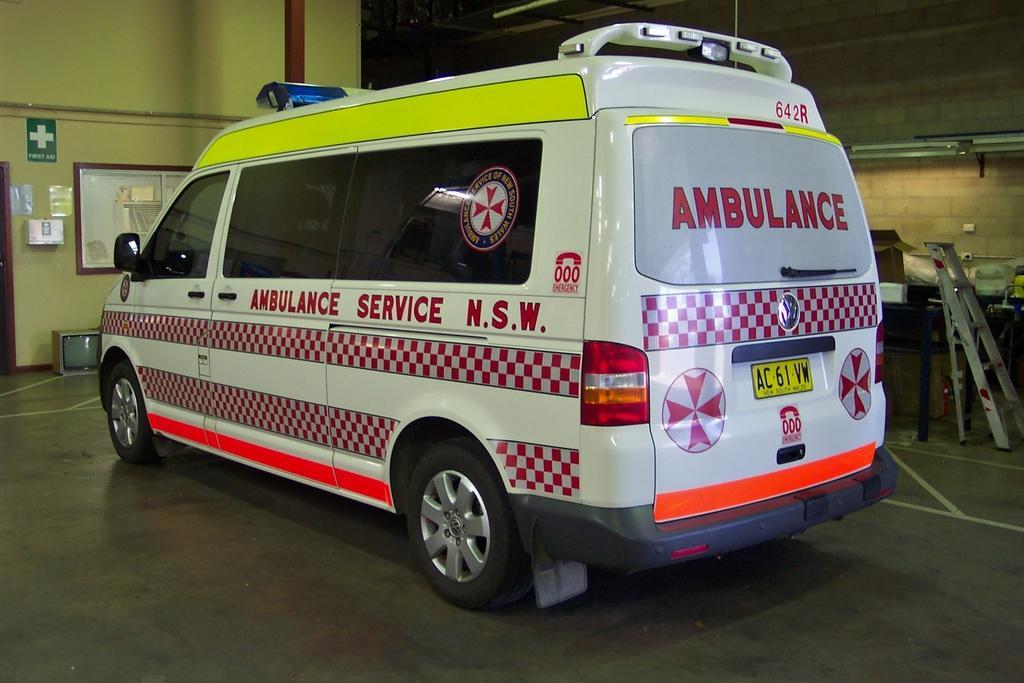In one or two sentences, can you explain what this image depicts? In this picture there is a vehicle and there is a text on the vehicle. On the left side of the image there is a board and there is a box and there are posters on the wall. There is a door and there is a television. On the right side of the image there is a ladder and there is a cardboard box and there are objects on the table. At the top there are lights and there are wires on the wall. 